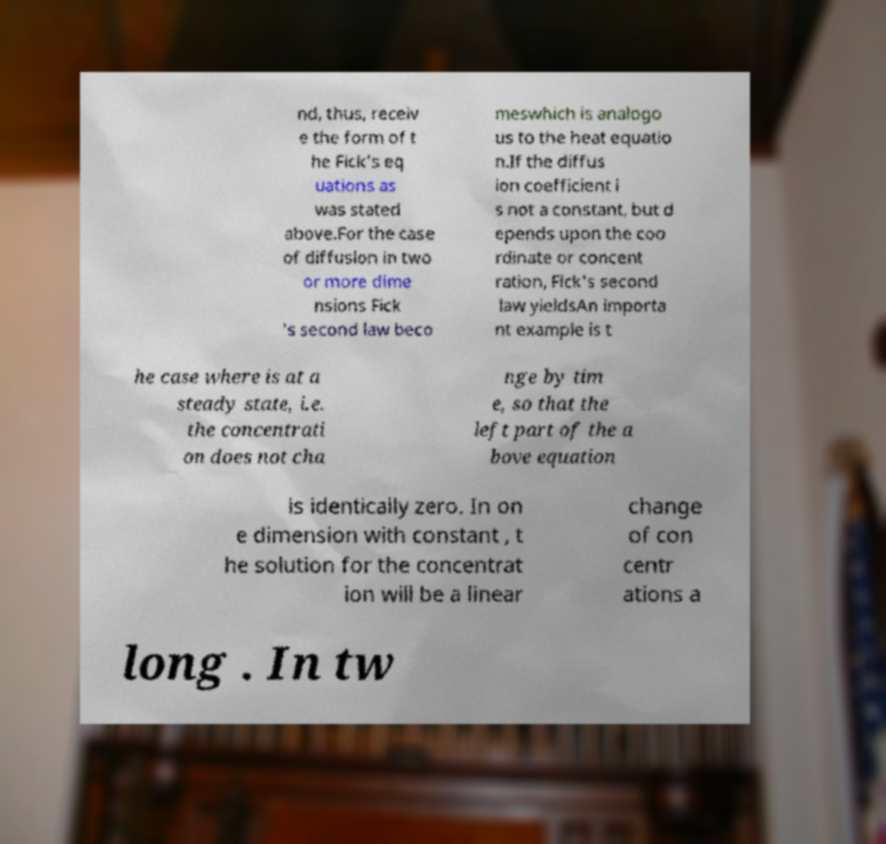What messages or text are displayed in this image? I need them in a readable, typed format. nd, thus, receiv e the form of t he Fick's eq uations as was stated above.For the case of diffusion in two or more dime nsions Fick 's second law beco meswhich is analogo us to the heat equatio n.If the diffus ion coefficient i s not a constant, but d epends upon the coo rdinate or concent ration, Fick's second law yieldsAn importa nt example is t he case where is at a steady state, i.e. the concentrati on does not cha nge by tim e, so that the left part of the a bove equation is identically zero. In on e dimension with constant , t he solution for the concentrat ion will be a linear change of con centr ations a long . In tw 